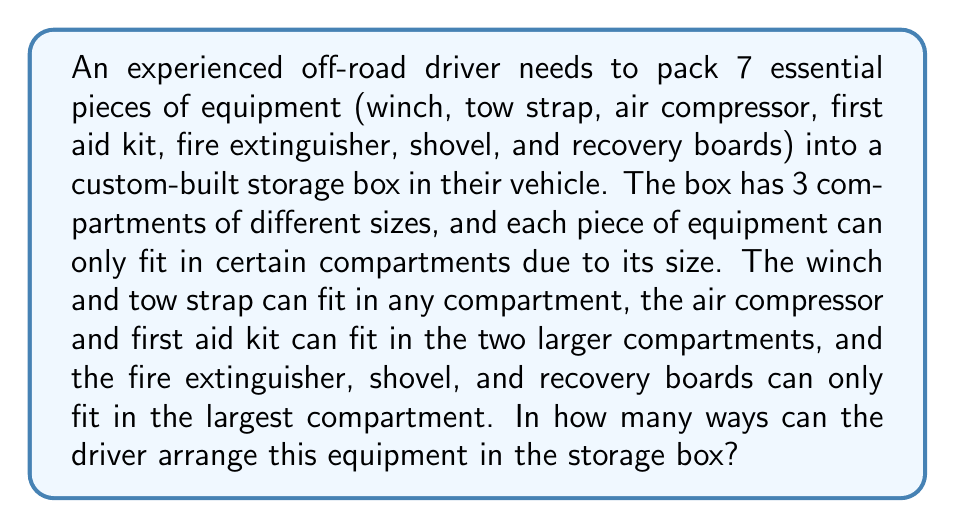Show me your answer to this math problem. Let's approach this step-by-step using the multiplication principle and the concept of distribution.

1) First, let's consider the largest compartment. It can hold all 7 items, but must contain at least the fire extinguisher, shovel, and recovery boards. We need to choose how many of the other 4 items will join these 3 in the largest compartment.

2) For each choice in step 1, we then need to distribute the remaining items between the two smaller compartments.

3) Let's break it down by cases:

   Case 1: Only the required 3 items in the largest compartment
   - Arrange these 3 items: $3! = 6$ ways
   - Distribute the remaining 4 items:
     * 2 items can go in either of the smaller compartments: $\binom{4}{2} = 6$ ways
     * For each distribution, arrange within compartments: $2! * 2! = 4$ ways
   Total for Case 1: $6 * 6 * 4 = 144$ ways

   Case 2: 4 items in the largest compartment
   - Choose 1 item to join the required 3: $\binom{4}{1} = 4$ ways
   - Arrange these 4 items: $4! = 24$ ways
   - Distribute the remaining 3 items:
     * 2 items in larger of small compartments, 1 in smallest: $3$ ways
     * For each distribution, arrange within compartments: $2! * 1! = 2$ ways
   Total for Case 2: $4 * 24 * 3 * 2 = 576$ ways

   Case 3: 5 items in the largest compartment
   - Choose 2 items to join the required 3: $\binom{4}{2} = 6$ ways
   - Arrange these 5 items: $5! = 120$ ways
   - Distribute the remaining 2 items:
     * 1 item in each of the smaller compartments: $2$ ways
   Total for Case 3: $6 * 120 * 2 = 1440$ ways

   Case 4: All 7 items in the largest compartment
   - Arrange all 7 items: $7! = 5040$ ways

4) The total number of ways is the sum of all cases:
   $144 + 576 + 1440 + 5040 = 7200$
Answer: $7200$ ways 